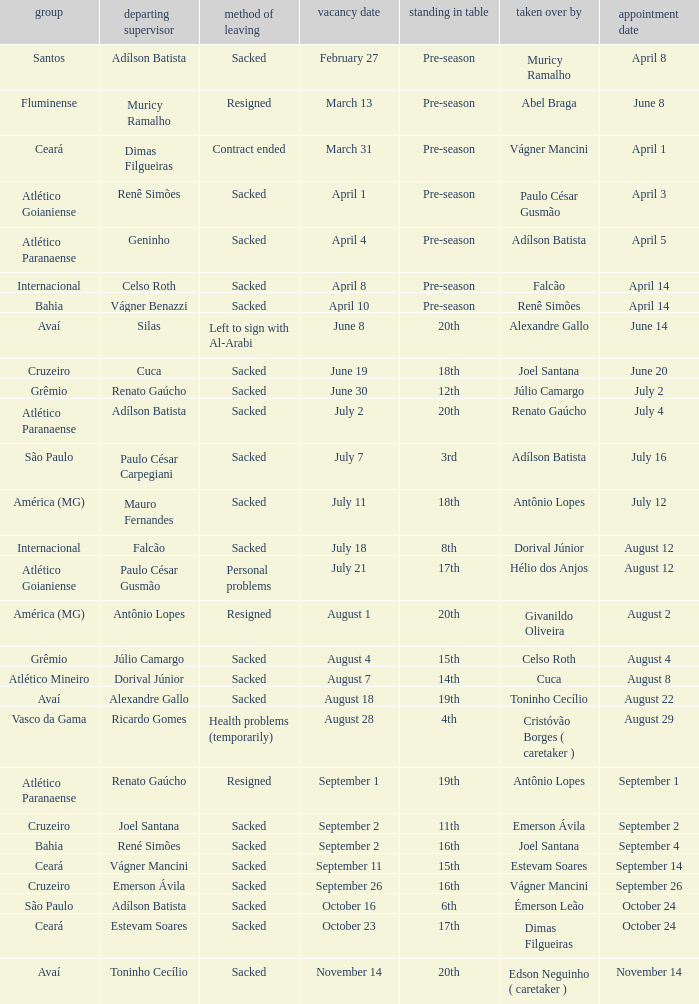Could you parse the entire table? {'header': ['group', 'departing supervisor', 'method of leaving', 'vacancy date', 'standing in table', 'taken over by', 'appointment date'], 'rows': [['Santos', 'Adílson Batista', 'Sacked', 'February 27', 'Pre-season', 'Muricy Ramalho', 'April 8'], ['Fluminense', 'Muricy Ramalho', 'Resigned', 'March 13', 'Pre-season', 'Abel Braga', 'June 8'], ['Ceará', 'Dimas Filgueiras', 'Contract ended', 'March 31', 'Pre-season', 'Vágner Mancini', 'April 1'], ['Atlético Goianiense', 'Renê Simões', 'Sacked', 'April 1', 'Pre-season', 'Paulo César Gusmão', 'April 3'], ['Atlético Paranaense', 'Geninho', 'Sacked', 'April 4', 'Pre-season', 'Adílson Batista', 'April 5'], ['Internacional', 'Celso Roth', 'Sacked', 'April 8', 'Pre-season', 'Falcão', 'April 14'], ['Bahia', 'Vágner Benazzi', 'Sacked', 'April 10', 'Pre-season', 'Renê Simões', 'April 14'], ['Avaí', 'Silas', 'Left to sign with Al-Arabi', 'June 8', '20th', 'Alexandre Gallo', 'June 14'], ['Cruzeiro', 'Cuca', 'Sacked', 'June 19', '18th', 'Joel Santana', 'June 20'], ['Grêmio', 'Renato Gaúcho', 'Sacked', 'June 30', '12th', 'Júlio Camargo', 'July 2'], ['Atlético Paranaense', 'Adílson Batista', 'Sacked', 'July 2', '20th', 'Renato Gaúcho', 'July 4'], ['São Paulo', 'Paulo César Carpegiani', 'Sacked', 'July 7', '3rd', 'Adílson Batista', 'July 16'], ['América (MG)', 'Mauro Fernandes', 'Sacked', 'July 11', '18th', 'Antônio Lopes', 'July 12'], ['Internacional', 'Falcão', 'Sacked', 'July 18', '8th', 'Dorival Júnior', 'August 12'], ['Atlético Goianiense', 'Paulo César Gusmão', 'Personal problems', 'July 21', '17th', 'Hélio dos Anjos', 'August 12'], ['América (MG)', 'Antônio Lopes', 'Resigned', 'August 1', '20th', 'Givanildo Oliveira', 'August 2'], ['Grêmio', 'Júlio Camargo', 'Sacked', 'August 4', '15th', 'Celso Roth', 'August 4'], ['Atlético Mineiro', 'Dorival Júnior', 'Sacked', 'August 7', '14th', 'Cuca', 'August 8'], ['Avaí', 'Alexandre Gallo', 'Sacked', 'August 18', '19th', 'Toninho Cecílio', 'August 22'], ['Vasco da Gama', 'Ricardo Gomes', 'Health problems (temporarily)', 'August 28', '4th', 'Cristóvão Borges ( caretaker )', 'August 29'], ['Atlético Paranaense', 'Renato Gaúcho', 'Resigned', 'September 1', '19th', 'Antônio Lopes', 'September 1'], ['Cruzeiro', 'Joel Santana', 'Sacked', 'September 2', '11th', 'Emerson Ávila', 'September 2'], ['Bahia', 'René Simões', 'Sacked', 'September 2', '16th', 'Joel Santana', 'September 4'], ['Ceará', 'Vágner Mancini', 'Sacked', 'September 11', '15th', 'Estevam Soares', 'September 14'], ['Cruzeiro', 'Emerson Ávila', 'Sacked', 'September 26', '16th', 'Vágner Mancini', 'September 26'], ['São Paulo', 'Adílson Batista', 'Sacked', 'October 16', '6th', 'Émerson Leão', 'October 24'], ['Ceará', 'Estevam Soares', 'Sacked', 'October 23', '17th', 'Dimas Filgueiras', 'October 24'], ['Avaí', 'Toninho Cecílio', 'Sacked', 'November 14', '20th', 'Edson Neguinho ( caretaker )', 'November 14']]} What team hired Renato Gaúcho? Atlético Paranaense. 